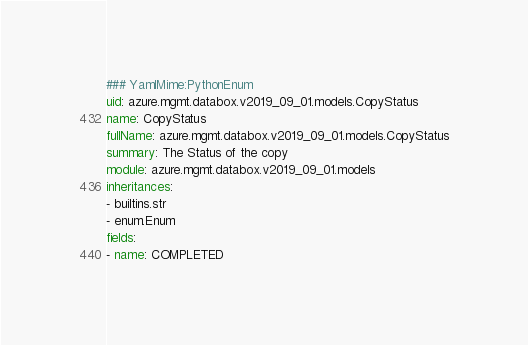<code> <loc_0><loc_0><loc_500><loc_500><_YAML_>### YamlMime:PythonEnum
uid: azure.mgmt.databox.v2019_09_01.models.CopyStatus
name: CopyStatus
fullName: azure.mgmt.databox.v2019_09_01.models.CopyStatus
summary: The Status of the copy
module: azure.mgmt.databox.v2019_09_01.models
inheritances:
- builtins.str
- enum.Enum
fields:
- name: COMPLETED</code> 